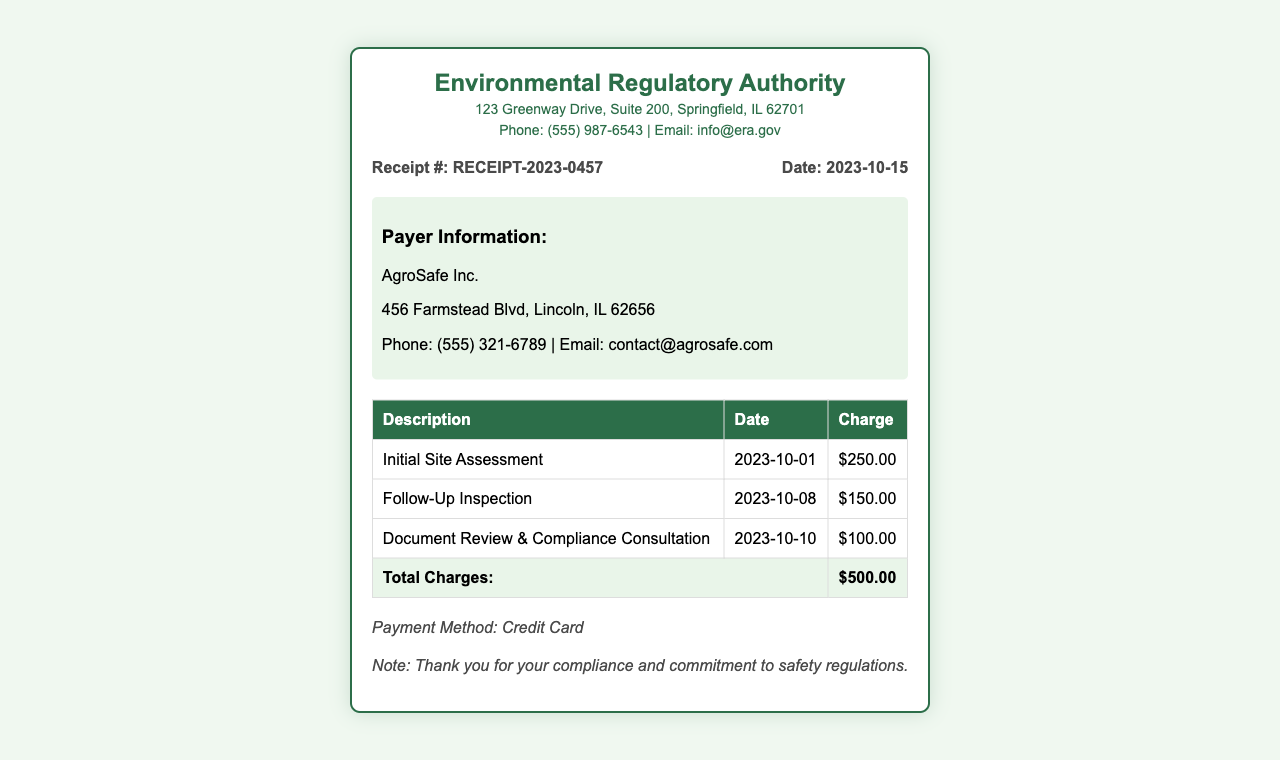What is the total charge? The total charge is listed at the end of the charges table, summing up all the individual charges.
Answer: $500.00 What is the date of the initial site assessment? The date of the initial site assessment is provided in the table under the Description column.
Answer: 2023-10-01 Who is the payer? The payer's name is clearly stated in the Payer Information section of the document.
Answer: AgroSafe Inc What was the charge for the follow-up inspection? The charge for the follow-up inspection is shown in the Charges table next to the corresponding description.
Answer: $150.00 What payment method was used? The payment method is indicated in the Payment Method section of the document.
Answer: Credit Card What is the receipt number? The receipt number is prominently displayed in the receipt details section.
Answer: RECEIPT-2023-0457 What is the date of the receipt? The date of the receipt is included in the receipt details section alongside the receipt number.
Answer: 2023-10-15 What type of consultation is included in the charges? The type of consultation appears in the description of the charge in the charges table.
Answer: Compliance Consultation What is the address of the Environmental Regulatory Authority? The address is mentioned in the header section of the document.
Answer: 123 Greenway Drive, Suite 200, Springfield, IL 62701 